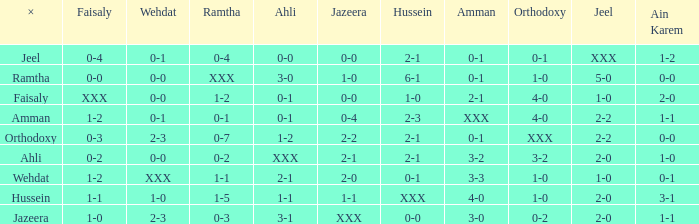What is ahli when ramtha is 0-4? 0-0. 